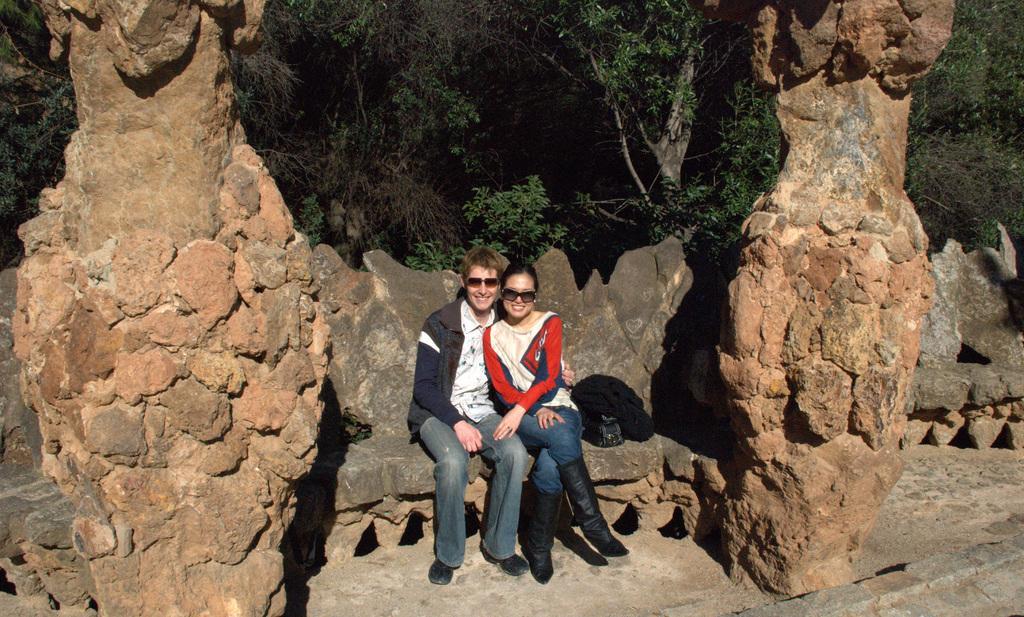Could you give a brief overview of what you see in this image? In this picture there are two persons sitting and smiling and there is a bag and there are rocks. At the back there are trees. 